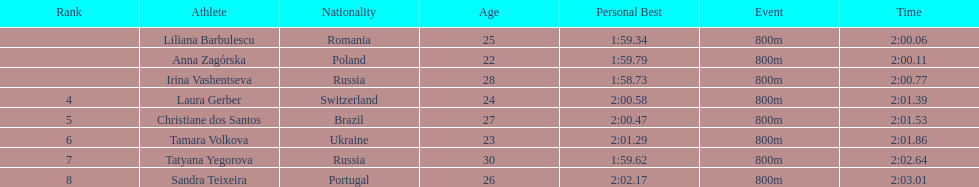How many runners finished with their time below 2:01? 3. 